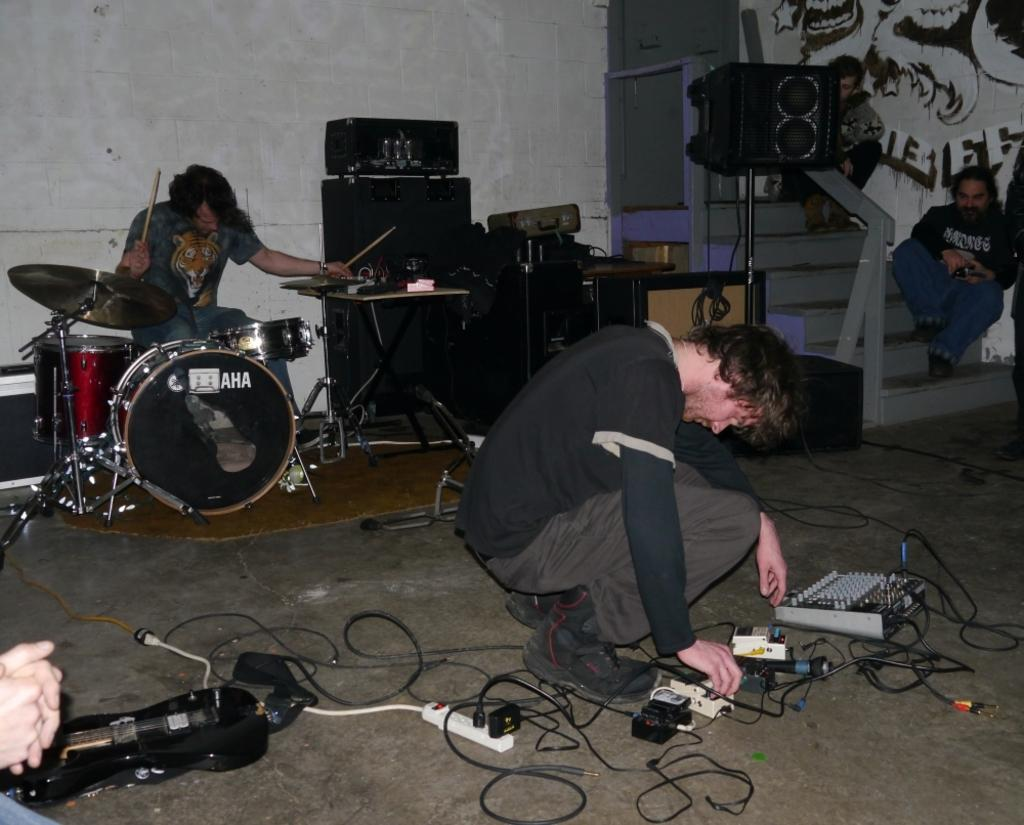What objects are present in the image related to music? There are musical instruments and speakers in the image. Can you describe the people in the image? There are people in the image, and two of them are sitting on a staircase. What additional objects can be seen in the image? There are wires and a switch board visible in the image. How many sticks does the son use to play the drums in the image? There is no son or drum set present in the image. What type of wire is being used to connect the musical instruments in the image? There is no wire connecting the musical instruments in the image; only wires are visible, but their purpose is not specified. 